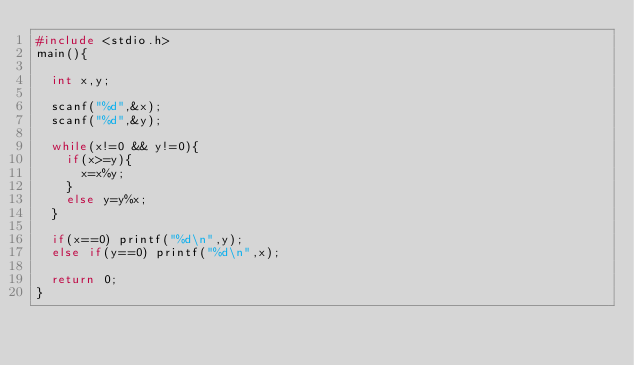Convert code to text. <code><loc_0><loc_0><loc_500><loc_500><_C_>#include <stdio.h>
main(){

  int x,y;

  scanf("%d",&x);
  scanf("%d",&y);

  while(x!=0 && y!=0){
    if(x>=y){
      x=x%y;
    }
    else y=y%x;
  }

  if(x==0) printf("%d\n",y);
  else if(y==0) printf("%d\n",x);

  return 0;
}</code> 